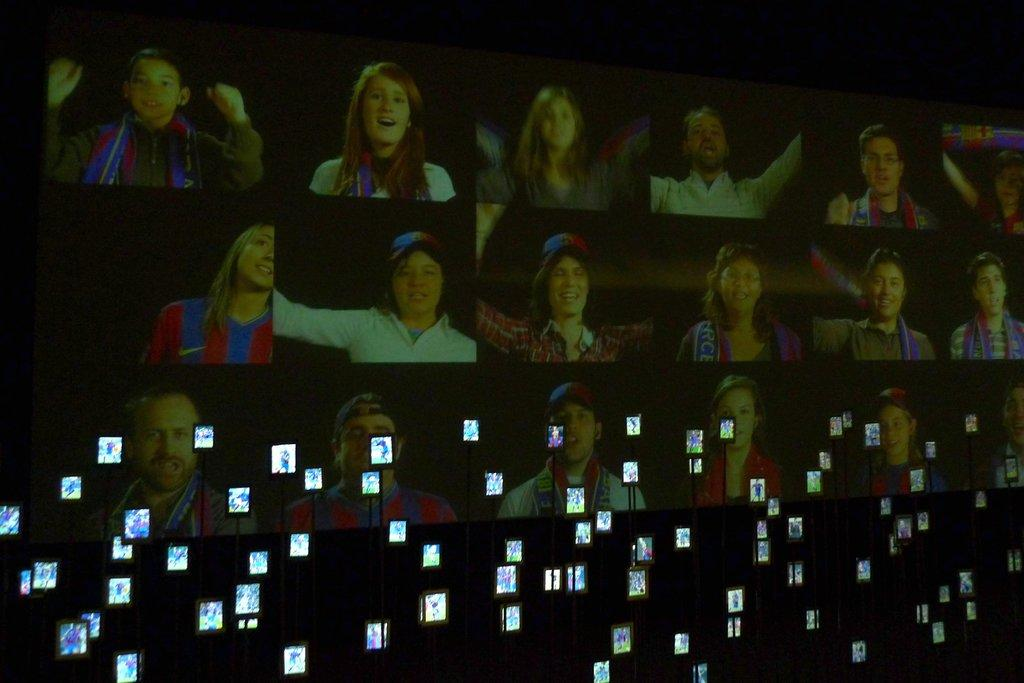What is the main object in the image? There is a screen in the image. What else can be seen at the bottom of the image? There are mobiles at the bottom of the image. What type of knee is visible in the image? There is no knee present in the image. Are there any slaves depicted in the image? There is no mention of slaves or any related context in the image. 